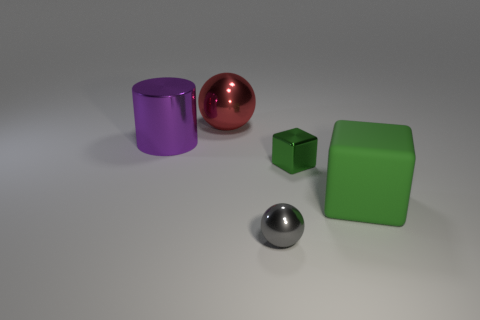Add 2 cylinders. How many objects exist? 7 Subtract all gray spheres. How many spheres are left? 1 Subtract all red cylinders. How many cyan cubes are left? 0 Subtract all large gray shiny things. Subtract all big green matte objects. How many objects are left? 4 Add 2 large purple metal things. How many large purple metal things are left? 3 Add 1 big green rubber objects. How many big green rubber objects exist? 2 Subtract 1 gray balls. How many objects are left? 4 Subtract all blocks. How many objects are left? 3 Subtract 1 spheres. How many spheres are left? 1 Subtract all purple blocks. Subtract all purple balls. How many blocks are left? 2 